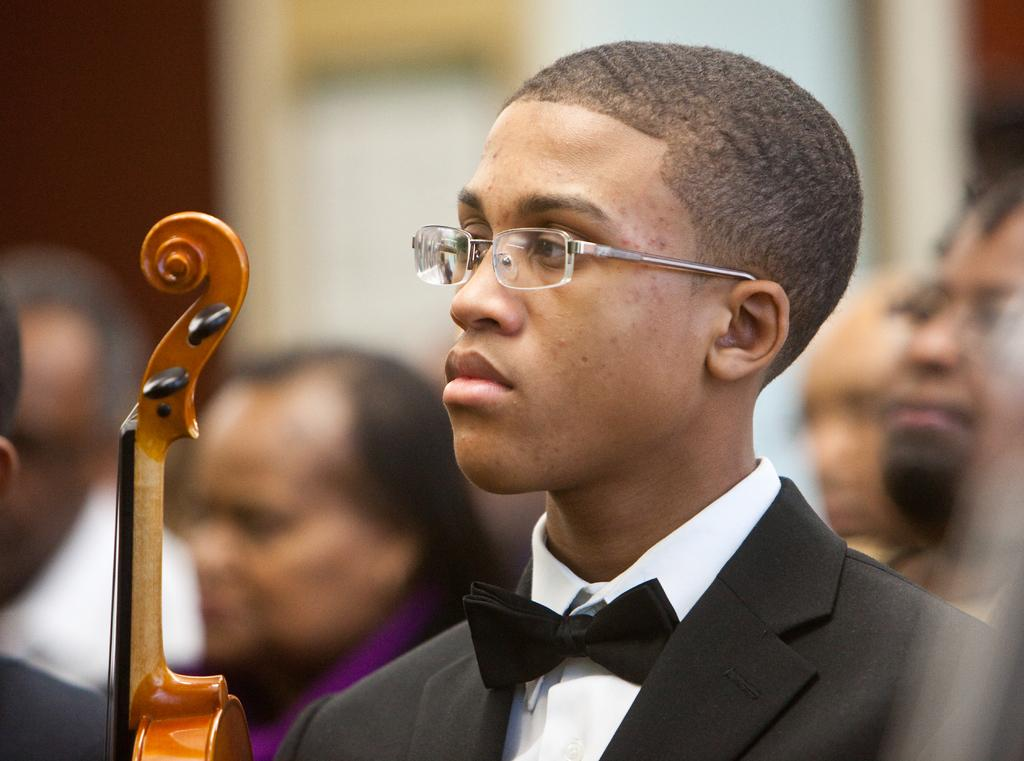Who is the main subject in the picture? The main subject in the picture is a boy. What can be observed about the boy's appearance? The boy is wearing spectacles. What is the boy doing in the picture? The boy is holding a musical instrument. What can be seen in the background of the picture? There are people and a wall visible in the background of the picture. How many pigs are visible in the picture? There are no pigs present in the picture. What type of place is depicted in the image? The image does not depict a specific place; it features a boy holding a musical instrument with people and a wall in the background. 